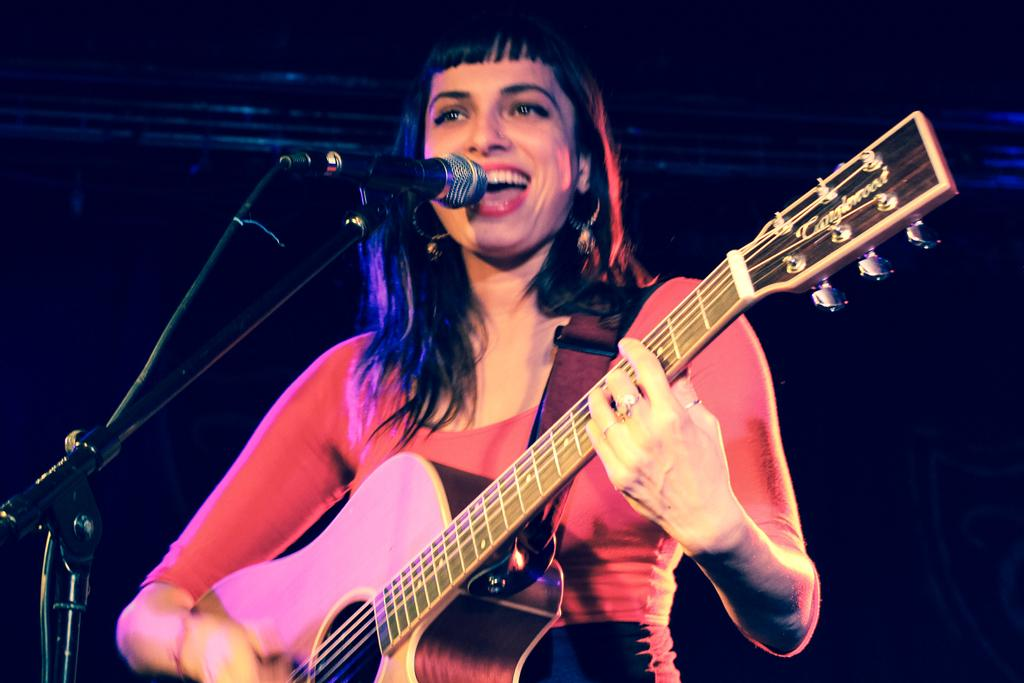What is the woman in the image doing? The woman is playing the guitar and singing on a microphone. What instrument is the woman holding in the image? The woman is holding a guitar in the image. What is the lighting condition in the background of the image? The background of the image is dark. What type of order is the woman taking in the image? There is no indication in the image that the woman is taking an order, as she is playing the guitar and singing on a microphone. Can you see any wires connected to the microphone in the image? The image does not show any wires connected to the microphone. 